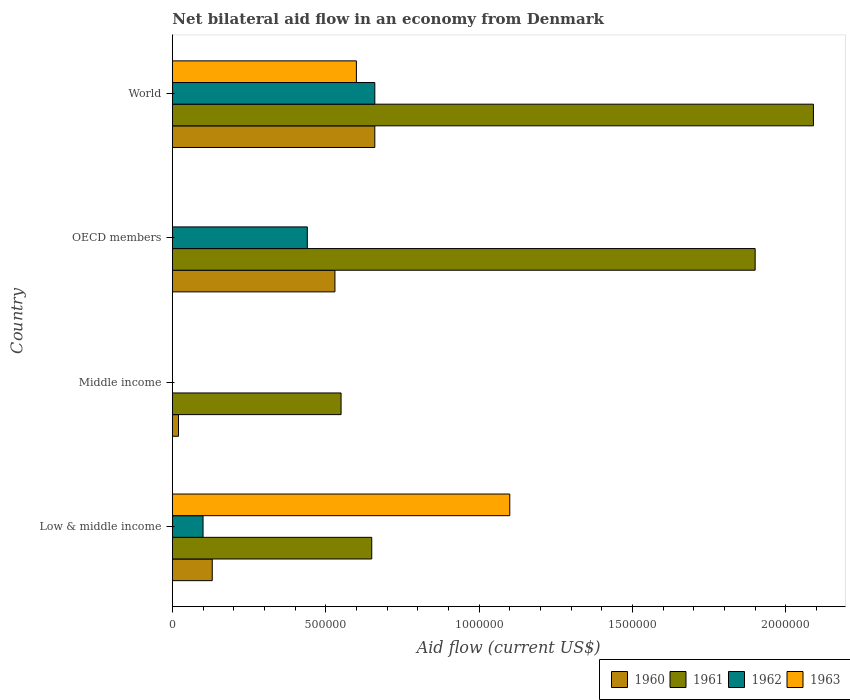Are the number of bars per tick equal to the number of legend labels?
Provide a short and direct response. No. Are the number of bars on each tick of the Y-axis equal?
Offer a very short reply. No. How many bars are there on the 1st tick from the top?
Provide a succinct answer. 4. What is the label of the 2nd group of bars from the top?
Make the answer very short. OECD members. In how many cases, is the number of bars for a given country not equal to the number of legend labels?
Keep it short and to the point. 2. What is the net bilateral aid flow in 1961 in Middle income?
Make the answer very short. 5.50e+05. Across all countries, what is the minimum net bilateral aid flow in 1963?
Offer a very short reply. 0. In which country was the net bilateral aid flow in 1960 maximum?
Provide a short and direct response. World. What is the total net bilateral aid flow in 1962 in the graph?
Make the answer very short. 1.20e+06. What is the difference between the net bilateral aid flow in 1960 in Middle income and the net bilateral aid flow in 1963 in World?
Your answer should be compact. -5.80e+05. What is the difference between the net bilateral aid flow in 1961 and net bilateral aid flow in 1960 in OECD members?
Give a very brief answer. 1.37e+06. In how many countries, is the net bilateral aid flow in 1960 greater than 300000 US$?
Give a very brief answer. 2. What is the ratio of the net bilateral aid flow in 1960 in Middle income to that in World?
Offer a terse response. 0.03. Is the net bilateral aid flow in 1960 in Low & middle income less than that in World?
Offer a terse response. Yes. Is the difference between the net bilateral aid flow in 1961 in Low & middle income and World greater than the difference between the net bilateral aid flow in 1960 in Low & middle income and World?
Provide a short and direct response. No. What is the difference between the highest and the lowest net bilateral aid flow in 1961?
Provide a succinct answer. 1.54e+06. Is it the case that in every country, the sum of the net bilateral aid flow in 1962 and net bilateral aid flow in 1963 is greater than the sum of net bilateral aid flow in 1960 and net bilateral aid flow in 1961?
Keep it short and to the point. No. How many bars are there?
Give a very brief answer. 13. Are all the bars in the graph horizontal?
Offer a terse response. Yes. Are the values on the major ticks of X-axis written in scientific E-notation?
Ensure brevity in your answer.  No. Does the graph contain any zero values?
Your response must be concise. Yes. Does the graph contain grids?
Ensure brevity in your answer.  No. Where does the legend appear in the graph?
Your answer should be compact. Bottom right. How are the legend labels stacked?
Your response must be concise. Horizontal. What is the title of the graph?
Provide a succinct answer. Net bilateral aid flow in an economy from Denmark. What is the label or title of the X-axis?
Offer a very short reply. Aid flow (current US$). What is the label or title of the Y-axis?
Your answer should be compact. Country. What is the Aid flow (current US$) in 1960 in Low & middle income?
Provide a short and direct response. 1.30e+05. What is the Aid flow (current US$) of 1961 in Low & middle income?
Your response must be concise. 6.50e+05. What is the Aid flow (current US$) in 1962 in Low & middle income?
Keep it short and to the point. 1.00e+05. What is the Aid flow (current US$) in 1963 in Low & middle income?
Ensure brevity in your answer.  1.10e+06. What is the Aid flow (current US$) in 1960 in Middle income?
Ensure brevity in your answer.  2.00e+04. What is the Aid flow (current US$) in 1963 in Middle income?
Your answer should be very brief. 0. What is the Aid flow (current US$) in 1960 in OECD members?
Your answer should be compact. 5.30e+05. What is the Aid flow (current US$) in 1961 in OECD members?
Your response must be concise. 1.90e+06. What is the Aid flow (current US$) in 1960 in World?
Offer a terse response. 6.60e+05. What is the Aid flow (current US$) of 1961 in World?
Offer a terse response. 2.09e+06. What is the Aid flow (current US$) of 1963 in World?
Ensure brevity in your answer.  6.00e+05. Across all countries, what is the maximum Aid flow (current US$) in 1961?
Give a very brief answer. 2.09e+06. Across all countries, what is the maximum Aid flow (current US$) in 1963?
Ensure brevity in your answer.  1.10e+06. Across all countries, what is the minimum Aid flow (current US$) of 1960?
Your response must be concise. 2.00e+04. Across all countries, what is the minimum Aid flow (current US$) in 1961?
Offer a very short reply. 5.50e+05. Across all countries, what is the minimum Aid flow (current US$) in 1962?
Provide a short and direct response. 0. Across all countries, what is the minimum Aid flow (current US$) in 1963?
Provide a succinct answer. 0. What is the total Aid flow (current US$) in 1960 in the graph?
Offer a very short reply. 1.34e+06. What is the total Aid flow (current US$) in 1961 in the graph?
Your response must be concise. 5.19e+06. What is the total Aid flow (current US$) of 1962 in the graph?
Make the answer very short. 1.20e+06. What is the total Aid flow (current US$) of 1963 in the graph?
Your answer should be compact. 1.70e+06. What is the difference between the Aid flow (current US$) of 1960 in Low & middle income and that in Middle income?
Make the answer very short. 1.10e+05. What is the difference between the Aid flow (current US$) of 1960 in Low & middle income and that in OECD members?
Offer a very short reply. -4.00e+05. What is the difference between the Aid flow (current US$) in 1961 in Low & middle income and that in OECD members?
Provide a short and direct response. -1.25e+06. What is the difference between the Aid flow (current US$) in 1960 in Low & middle income and that in World?
Offer a very short reply. -5.30e+05. What is the difference between the Aid flow (current US$) in 1961 in Low & middle income and that in World?
Give a very brief answer. -1.44e+06. What is the difference between the Aid flow (current US$) in 1962 in Low & middle income and that in World?
Ensure brevity in your answer.  -5.60e+05. What is the difference between the Aid flow (current US$) of 1963 in Low & middle income and that in World?
Keep it short and to the point. 5.00e+05. What is the difference between the Aid flow (current US$) of 1960 in Middle income and that in OECD members?
Your answer should be compact. -5.10e+05. What is the difference between the Aid flow (current US$) of 1961 in Middle income and that in OECD members?
Provide a succinct answer. -1.35e+06. What is the difference between the Aid flow (current US$) in 1960 in Middle income and that in World?
Your answer should be compact. -6.40e+05. What is the difference between the Aid flow (current US$) in 1961 in Middle income and that in World?
Your response must be concise. -1.54e+06. What is the difference between the Aid flow (current US$) of 1960 in OECD members and that in World?
Your answer should be very brief. -1.30e+05. What is the difference between the Aid flow (current US$) in 1962 in OECD members and that in World?
Provide a short and direct response. -2.20e+05. What is the difference between the Aid flow (current US$) in 1960 in Low & middle income and the Aid flow (current US$) in 1961 in Middle income?
Your answer should be very brief. -4.20e+05. What is the difference between the Aid flow (current US$) in 1960 in Low & middle income and the Aid flow (current US$) in 1961 in OECD members?
Offer a terse response. -1.77e+06. What is the difference between the Aid flow (current US$) of 1960 in Low & middle income and the Aid flow (current US$) of 1962 in OECD members?
Your response must be concise. -3.10e+05. What is the difference between the Aid flow (current US$) in 1960 in Low & middle income and the Aid flow (current US$) in 1961 in World?
Give a very brief answer. -1.96e+06. What is the difference between the Aid flow (current US$) in 1960 in Low & middle income and the Aid flow (current US$) in 1962 in World?
Your answer should be very brief. -5.30e+05. What is the difference between the Aid flow (current US$) in 1960 in Low & middle income and the Aid flow (current US$) in 1963 in World?
Give a very brief answer. -4.70e+05. What is the difference between the Aid flow (current US$) in 1961 in Low & middle income and the Aid flow (current US$) in 1962 in World?
Provide a short and direct response. -10000. What is the difference between the Aid flow (current US$) of 1962 in Low & middle income and the Aid flow (current US$) of 1963 in World?
Offer a very short reply. -5.00e+05. What is the difference between the Aid flow (current US$) of 1960 in Middle income and the Aid flow (current US$) of 1961 in OECD members?
Make the answer very short. -1.88e+06. What is the difference between the Aid flow (current US$) of 1960 in Middle income and the Aid flow (current US$) of 1962 in OECD members?
Your answer should be very brief. -4.20e+05. What is the difference between the Aid flow (current US$) in 1960 in Middle income and the Aid flow (current US$) in 1961 in World?
Offer a very short reply. -2.07e+06. What is the difference between the Aid flow (current US$) of 1960 in Middle income and the Aid flow (current US$) of 1962 in World?
Give a very brief answer. -6.40e+05. What is the difference between the Aid flow (current US$) in 1960 in Middle income and the Aid flow (current US$) in 1963 in World?
Offer a very short reply. -5.80e+05. What is the difference between the Aid flow (current US$) of 1961 in Middle income and the Aid flow (current US$) of 1962 in World?
Your answer should be compact. -1.10e+05. What is the difference between the Aid flow (current US$) of 1960 in OECD members and the Aid flow (current US$) of 1961 in World?
Your answer should be very brief. -1.56e+06. What is the difference between the Aid flow (current US$) in 1960 in OECD members and the Aid flow (current US$) in 1962 in World?
Your answer should be very brief. -1.30e+05. What is the difference between the Aid flow (current US$) of 1960 in OECD members and the Aid flow (current US$) of 1963 in World?
Make the answer very short. -7.00e+04. What is the difference between the Aid flow (current US$) in 1961 in OECD members and the Aid flow (current US$) in 1962 in World?
Make the answer very short. 1.24e+06. What is the difference between the Aid flow (current US$) in 1961 in OECD members and the Aid flow (current US$) in 1963 in World?
Offer a terse response. 1.30e+06. What is the average Aid flow (current US$) of 1960 per country?
Offer a very short reply. 3.35e+05. What is the average Aid flow (current US$) in 1961 per country?
Provide a short and direct response. 1.30e+06. What is the average Aid flow (current US$) in 1962 per country?
Your response must be concise. 3.00e+05. What is the average Aid flow (current US$) of 1963 per country?
Make the answer very short. 4.25e+05. What is the difference between the Aid flow (current US$) of 1960 and Aid flow (current US$) of 1961 in Low & middle income?
Provide a succinct answer. -5.20e+05. What is the difference between the Aid flow (current US$) of 1960 and Aid flow (current US$) of 1963 in Low & middle income?
Give a very brief answer. -9.70e+05. What is the difference between the Aid flow (current US$) in 1961 and Aid flow (current US$) in 1962 in Low & middle income?
Offer a very short reply. 5.50e+05. What is the difference between the Aid flow (current US$) of 1961 and Aid flow (current US$) of 1963 in Low & middle income?
Offer a very short reply. -4.50e+05. What is the difference between the Aid flow (current US$) in 1960 and Aid flow (current US$) in 1961 in Middle income?
Provide a short and direct response. -5.30e+05. What is the difference between the Aid flow (current US$) of 1960 and Aid flow (current US$) of 1961 in OECD members?
Keep it short and to the point. -1.37e+06. What is the difference between the Aid flow (current US$) in 1960 and Aid flow (current US$) in 1962 in OECD members?
Provide a succinct answer. 9.00e+04. What is the difference between the Aid flow (current US$) in 1961 and Aid flow (current US$) in 1962 in OECD members?
Keep it short and to the point. 1.46e+06. What is the difference between the Aid flow (current US$) of 1960 and Aid flow (current US$) of 1961 in World?
Provide a succinct answer. -1.43e+06. What is the difference between the Aid flow (current US$) in 1961 and Aid flow (current US$) in 1962 in World?
Provide a short and direct response. 1.43e+06. What is the difference between the Aid flow (current US$) of 1961 and Aid flow (current US$) of 1963 in World?
Give a very brief answer. 1.49e+06. What is the difference between the Aid flow (current US$) of 1962 and Aid flow (current US$) of 1963 in World?
Keep it short and to the point. 6.00e+04. What is the ratio of the Aid flow (current US$) in 1960 in Low & middle income to that in Middle income?
Offer a very short reply. 6.5. What is the ratio of the Aid flow (current US$) of 1961 in Low & middle income to that in Middle income?
Offer a terse response. 1.18. What is the ratio of the Aid flow (current US$) in 1960 in Low & middle income to that in OECD members?
Offer a very short reply. 0.25. What is the ratio of the Aid flow (current US$) of 1961 in Low & middle income to that in OECD members?
Ensure brevity in your answer.  0.34. What is the ratio of the Aid flow (current US$) of 1962 in Low & middle income to that in OECD members?
Offer a very short reply. 0.23. What is the ratio of the Aid flow (current US$) in 1960 in Low & middle income to that in World?
Give a very brief answer. 0.2. What is the ratio of the Aid flow (current US$) in 1961 in Low & middle income to that in World?
Your answer should be compact. 0.31. What is the ratio of the Aid flow (current US$) in 1962 in Low & middle income to that in World?
Your answer should be compact. 0.15. What is the ratio of the Aid flow (current US$) in 1963 in Low & middle income to that in World?
Give a very brief answer. 1.83. What is the ratio of the Aid flow (current US$) of 1960 in Middle income to that in OECD members?
Make the answer very short. 0.04. What is the ratio of the Aid flow (current US$) in 1961 in Middle income to that in OECD members?
Your answer should be compact. 0.29. What is the ratio of the Aid flow (current US$) of 1960 in Middle income to that in World?
Your response must be concise. 0.03. What is the ratio of the Aid flow (current US$) in 1961 in Middle income to that in World?
Your answer should be very brief. 0.26. What is the ratio of the Aid flow (current US$) of 1960 in OECD members to that in World?
Your answer should be compact. 0.8. What is the ratio of the Aid flow (current US$) of 1961 in OECD members to that in World?
Keep it short and to the point. 0.91. What is the difference between the highest and the second highest Aid flow (current US$) in 1960?
Provide a short and direct response. 1.30e+05. What is the difference between the highest and the second highest Aid flow (current US$) of 1962?
Offer a very short reply. 2.20e+05. What is the difference between the highest and the lowest Aid flow (current US$) of 1960?
Your response must be concise. 6.40e+05. What is the difference between the highest and the lowest Aid flow (current US$) of 1961?
Offer a terse response. 1.54e+06. What is the difference between the highest and the lowest Aid flow (current US$) of 1963?
Offer a terse response. 1.10e+06. 